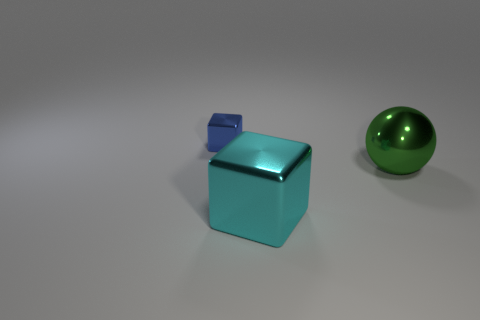There is a thing on the right side of the block that is in front of the tiny metallic cube that is behind the green ball; how big is it?
Your response must be concise. Large. There is a green metal thing that is the same size as the cyan object; what shape is it?
Provide a succinct answer. Sphere. What number of large objects are either rubber cylinders or green objects?
Offer a very short reply. 1. Is there a blue object right of the large shiny object behind the cube in front of the tiny blue cube?
Offer a terse response. No. Is there another green shiny thing that has the same size as the green object?
Make the answer very short. No. There is another thing that is the same size as the cyan metallic object; what is its material?
Offer a terse response. Metal. There is a green metallic ball; does it have the same size as the shiny cube in front of the tiny blue thing?
Your answer should be very brief. Yes. What number of matte things are either big cyan things or large cyan balls?
Your response must be concise. 0. What number of small things have the same shape as the big green shiny object?
Offer a very short reply. 0. Does the shiny cube in front of the tiny object have the same size as the cube that is behind the large green metallic ball?
Ensure brevity in your answer.  No. 